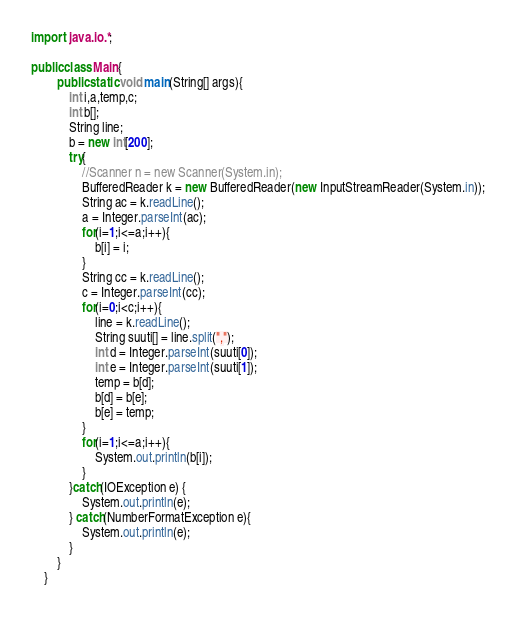<code> <loc_0><loc_0><loc_500><loc_500><_Java_>import  java.io.*;

public class Main{ 
        public static void main(String[] args){
            int i,a,temp,c;
            int b[];
            String line;
            b = new int[200];
            try{
                //Scanner n = new Scanner(System.in);
                BufferedReader k = new BufferedReader(new InputStreamReader(System.in));
                String ac = k.readLine();
                a = Integer.parseInt(ac);
                for(i=1;i<=a;i++){
                    b[i] = i;
                }
                String cc = k.readLine();
                c = Integer.parseInt(cc);
                for(i=0;i<c;i++){
                    line = k.readLine();
                    String suuti[] = line.split(",");
                    int d = Integer.parseInt(suuti[0]);
                    int e = Integer.parseInt(suuti[1]);
                    temp = b[d];
                    b[d] = b[e];
                    b[e] = temp;
                }
                for(i=1;i<=a;i++){
                    System.out.println(b[i]);
                }
            }catch(IOException e) {
                System.out.println(e);
            } catch(NumberFormatException e){
                System.out.println(e);
            }
        }
    }
</code> 